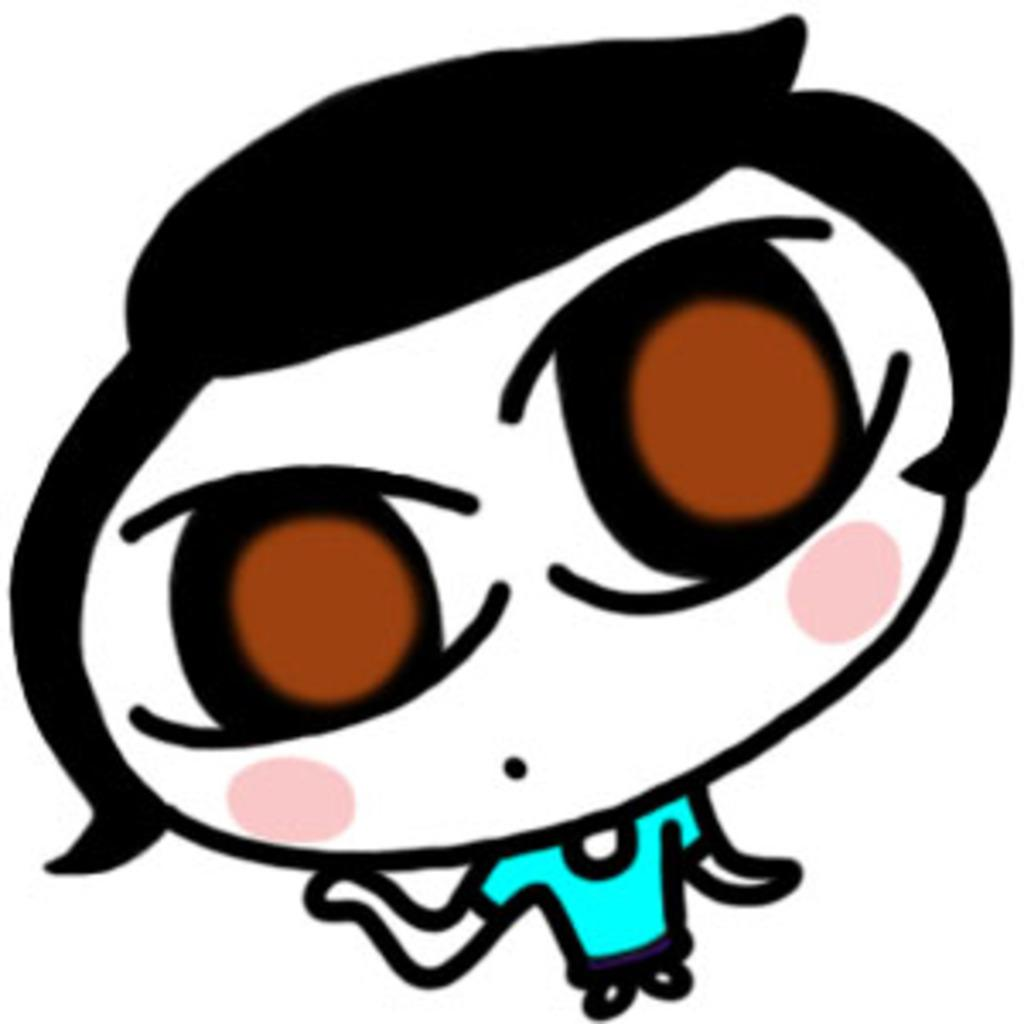What type of image is being described? The image is animated. Can you describe the person in the image? There is a person in the image. What is the person wearing? The person is wearing a blue t-shirt. What type of instrument is the person playing in the image? There is no instrument present in the image; the person is simply wearing a blue t-shirt. 